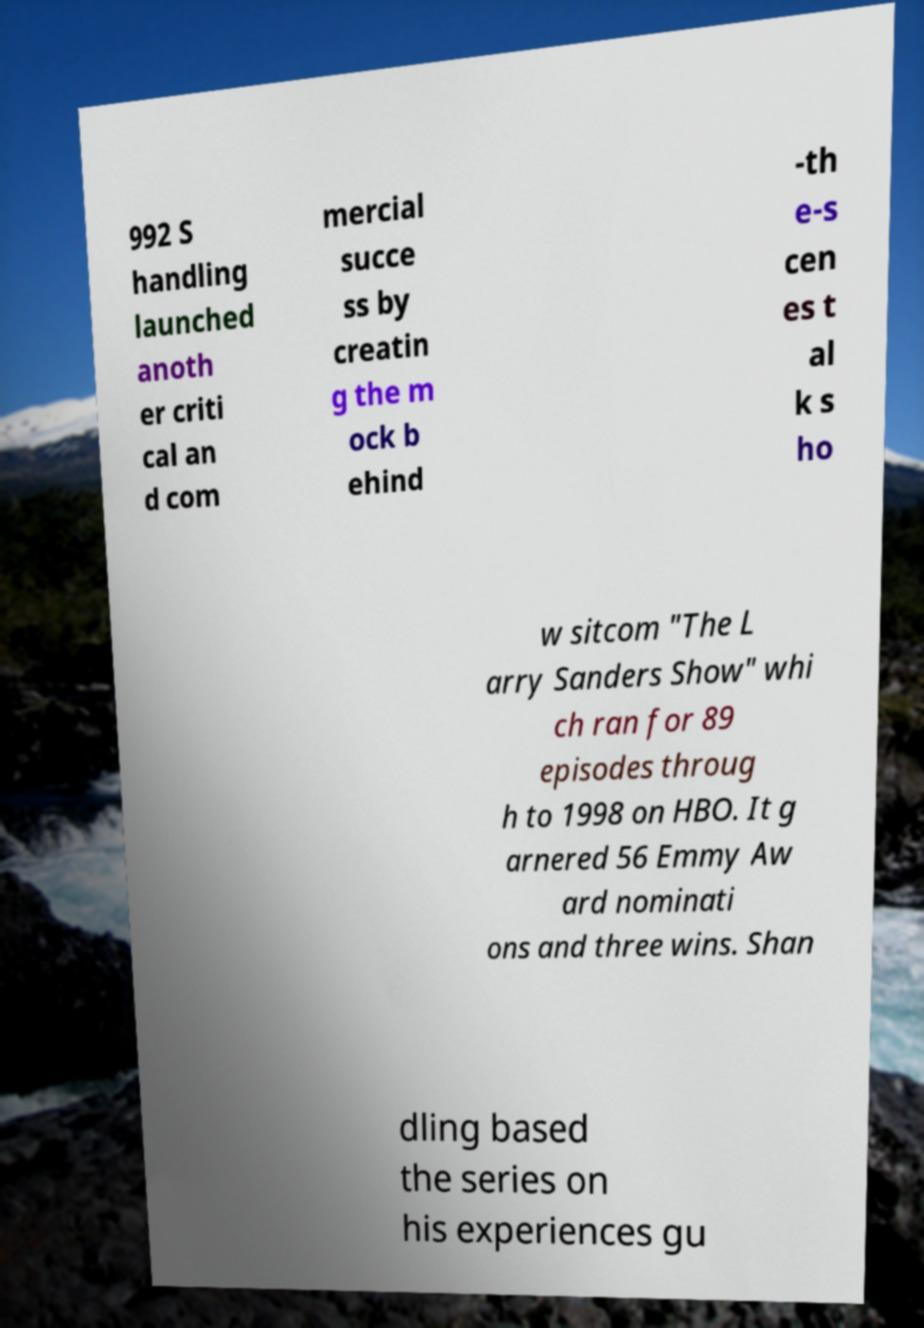What messages or text are displayed in this image? I need them in a readable, typed format. 992 S handling launched anoth er criti cal an d com mercial succe ss by creatin g the m ock b ehind -th e-s cen es t al k s ho w sitcom "The L arry Sanders Show" whi ch ran for 89 episodes throug h to 1998 on HBO. It g arnered 56 Emmy Aw ard nominati ons and three wins. Shan dling based the series on his experiences gu 